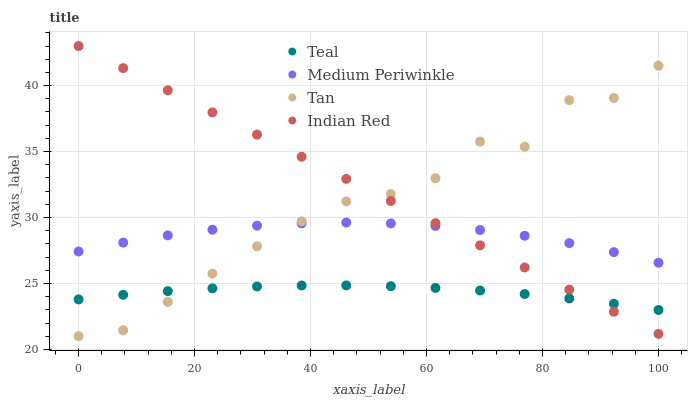Does Teal have the minimum area under the curve?
Answer yes or no. Yes. Does Indian Red have the maximum area under the curve?
Answer yes or no. Yes. Does Medium Periwinkle have the minimum area under the curve?
Answer yes or no. No. Does Medium Periwinkle have the maximum area under the curve?
Answer yes or no. No. Is Indian Red the smoothest?
Answer yes or no. Yes. Is Tan the roughest?
Answer yes or no. Yes. Is Medium Periwinkle the smoothest?
Answer yes or no. No. Is Medium Periwinkle the roughest?
Answer yes or no. No. Does Tan have the lowest value?
Answer yes or no. Yes. Does Indian Red have the lowest value?
Answer yes or no. No. Does Indian Red have the highest value?
Answer yes or no. Yes. Does Medium Periwinkle have the highest value?
Answer yes or no. No. Is Teal less than Medium Periwinkle?
Answer yes or no. Yes. Is Medium Periwinkle greater than Teal?
Answer yes or no. Yes. Does Medium Periwinkle intersect Indian Red?
Answer yes or no. Yes. Is Medium Periwinkle less than Indian Red?
Answer yes or no. No. Is Medium Periwinkle greater than Indian Red?
Answer yes or no. No. Does Teal intersect Medium Periwinkle?
Answer yes or no. No. 